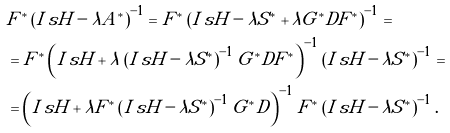<formula> <loc_0><loc_0><loc_500><loc_500>& F ^ { * } \left ( I _ { \ } s H - \lambda A ^ { * } \right ) ^ { - 1 } = F ^ { * } \left ( I _ { \ } s H - \lambda S ^ { * } + \lambda G ^ { * } D F ^ { * } \right ) ^ { - 1 } = \\ & = F ^ { * } \left ( I _ { \ } s H + \lambda \left ( I _ { \ } s H - \lambda S ^ { * } \right ) ^ { - 1 } G ^ { * } D F ^ { * } \right ) ^ { - 1 } \left ( I _ { \ } s H - \lambda S ^ { * } \right ) ^ { - 1 } = \\ & = \left ( I _ { \ } s H + \lambda F ^ { * } \left ( I _ { \ } s H - \lambda S ^ { * } \right ) ^ { - 1 } G ^ { * } D \right ) ^ { - 1 } F ^ { * } \left ( I _ { \ } s H - \lambda S ^ { * } \right ) ^ { - 1 } .</formula> 